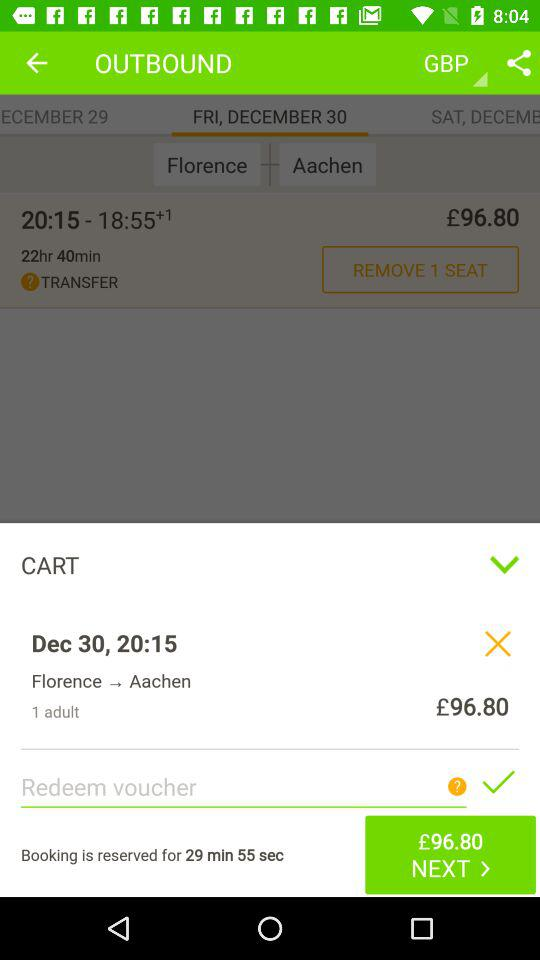What is the source station given on the screen? The source station given on the screen is Florence. 